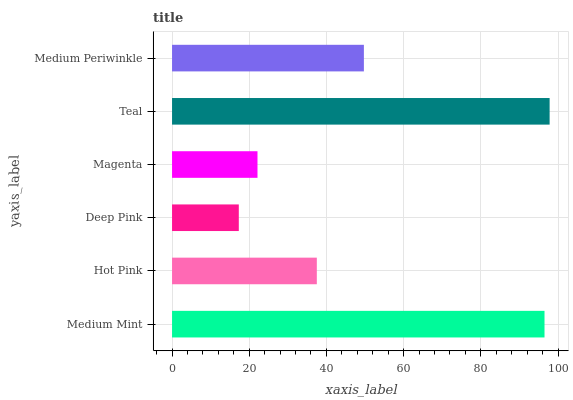Is Deep Pink the minimum?
Answer yes or no. Yes. Is Teal the maximum?
Answer yes or no. Yes. Is Hot Pink the minimum?
Answer yes or no. No. Is Hot Pink the maximum?
Answer yes or no. No. Is Medium Mint greater than Hot Pink?
Answer yes or no. Yes. Is Hot Pink less than Medium Mint?
Answer yes or no. Yes. Is Hot Pink greater than Medium Mint?
Answer yes or no. No. Is Medium Mint less than Hot Pink?
Answer yes or no. No. Is Medium Periwinkle the high median?
Answer yes or no. Yes. Is Hot Pink the low median?
Answer yes or no. Yes. Is Deep Pink the high median?
Answer yes or no. No. Is Teal the low median?
Answer yes or no. No. 